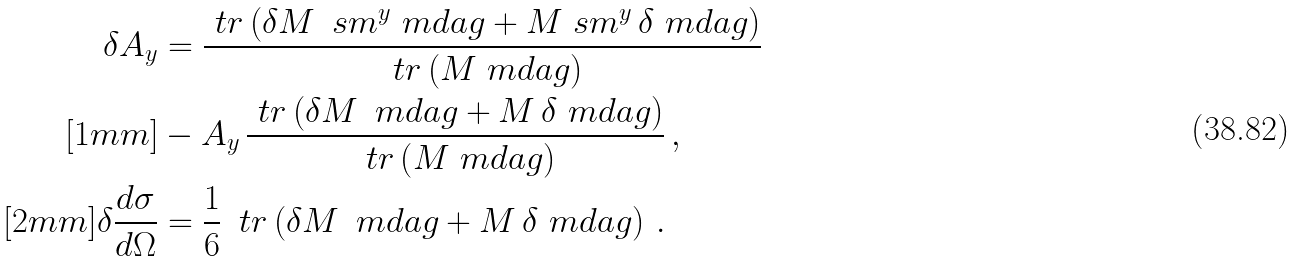<formula> <loc_0><loc_0><loc_500><loc_500>\delta A _ { y } & = \frac { \ t r \left ( \delta M \, \ s m ^ { y } \ m d a g + M \ s m ^ { y } \, \delta \ m d a g \right ) } { \ t r \left ( M \ m d a g \right ) } \\ [ 1 m m ] & - A _ { y } \, \frac { \ t r \left ( \delta M \, \ m d a g + M \, \delta \ m d a g \right ) } { \ t r \left ( M \ m d a g \right ) } \, , \\ [ 2 m m ] \delta \frac { d \sigma } { d \Omega } & = \frac { 1 } { 6 } \, \ t r \left ( \delta M \, \ m d a g + M \, \delta \ m d a g \right ) \, .</formula> 